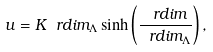<formula> <loc_0><loc_0><loc_500><loc_500>u = K \ r d i m _ { \Lambda } \sinh \left ( \frac { \ r d i m } { \ r d i m _ { \Lambda } } \right ) ,</formula> 